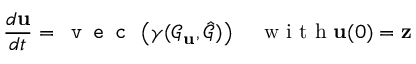Convert formula to latex. <formula><loc_0><loc_0><loc_500><loc_500>\frac { d u } { d t } = v e c \left ( \gamma ( \mathcal { G } _ { u } , \hat { \mathcal { G } } ) \right ) \quad w i t h u ( 0 ) = z</formula> 